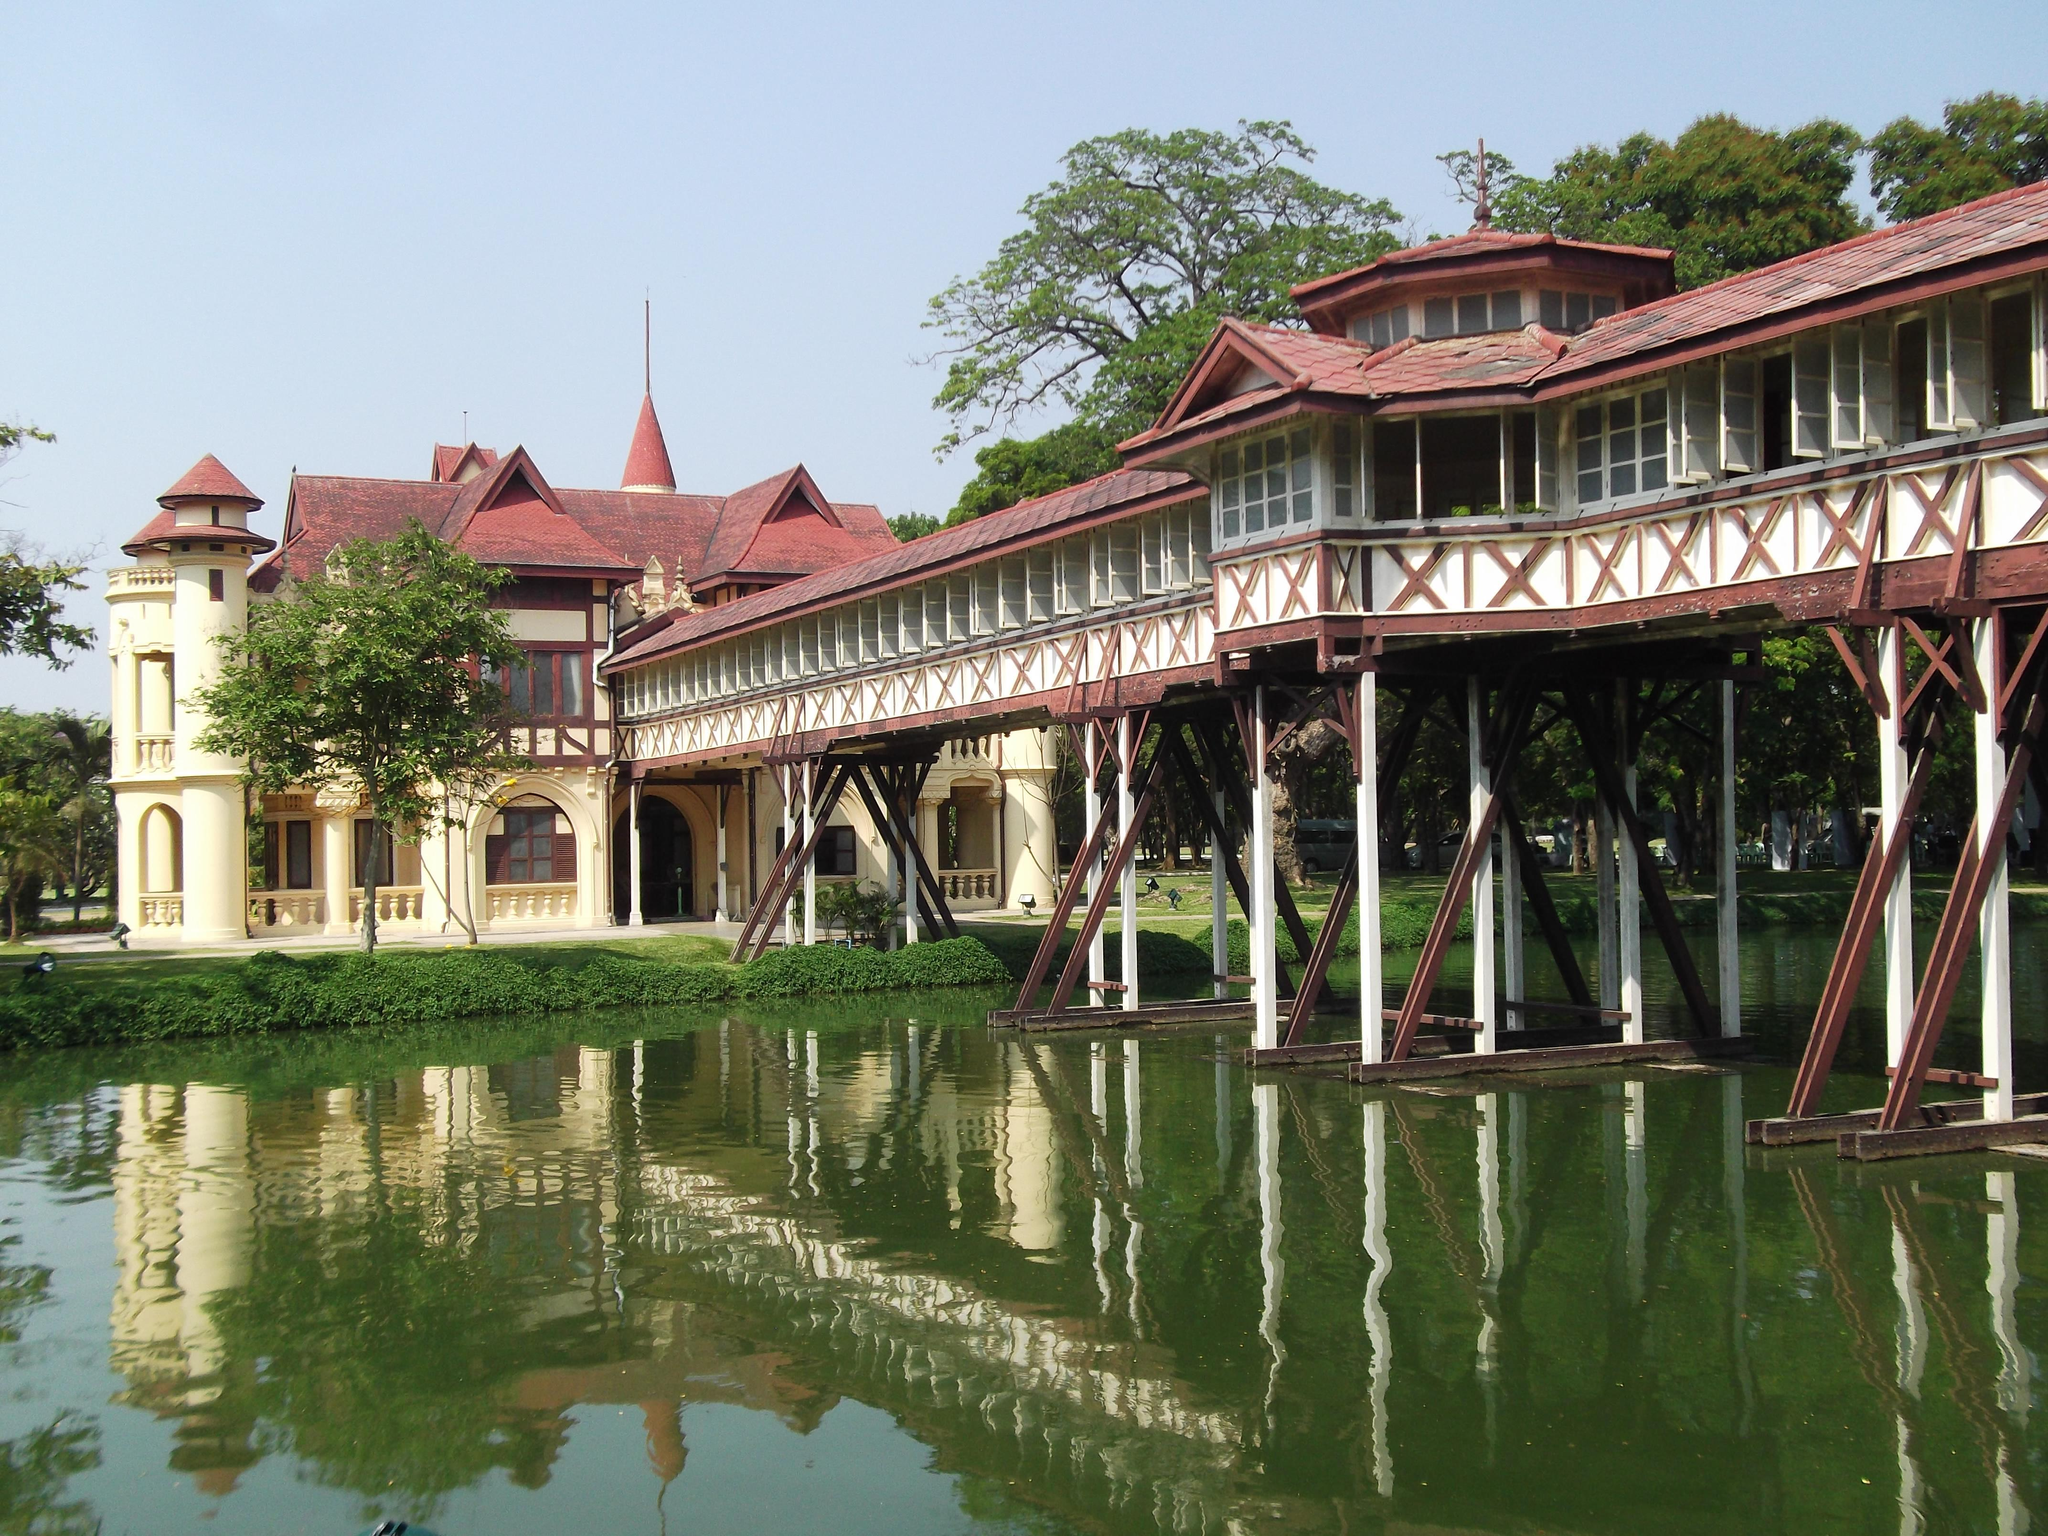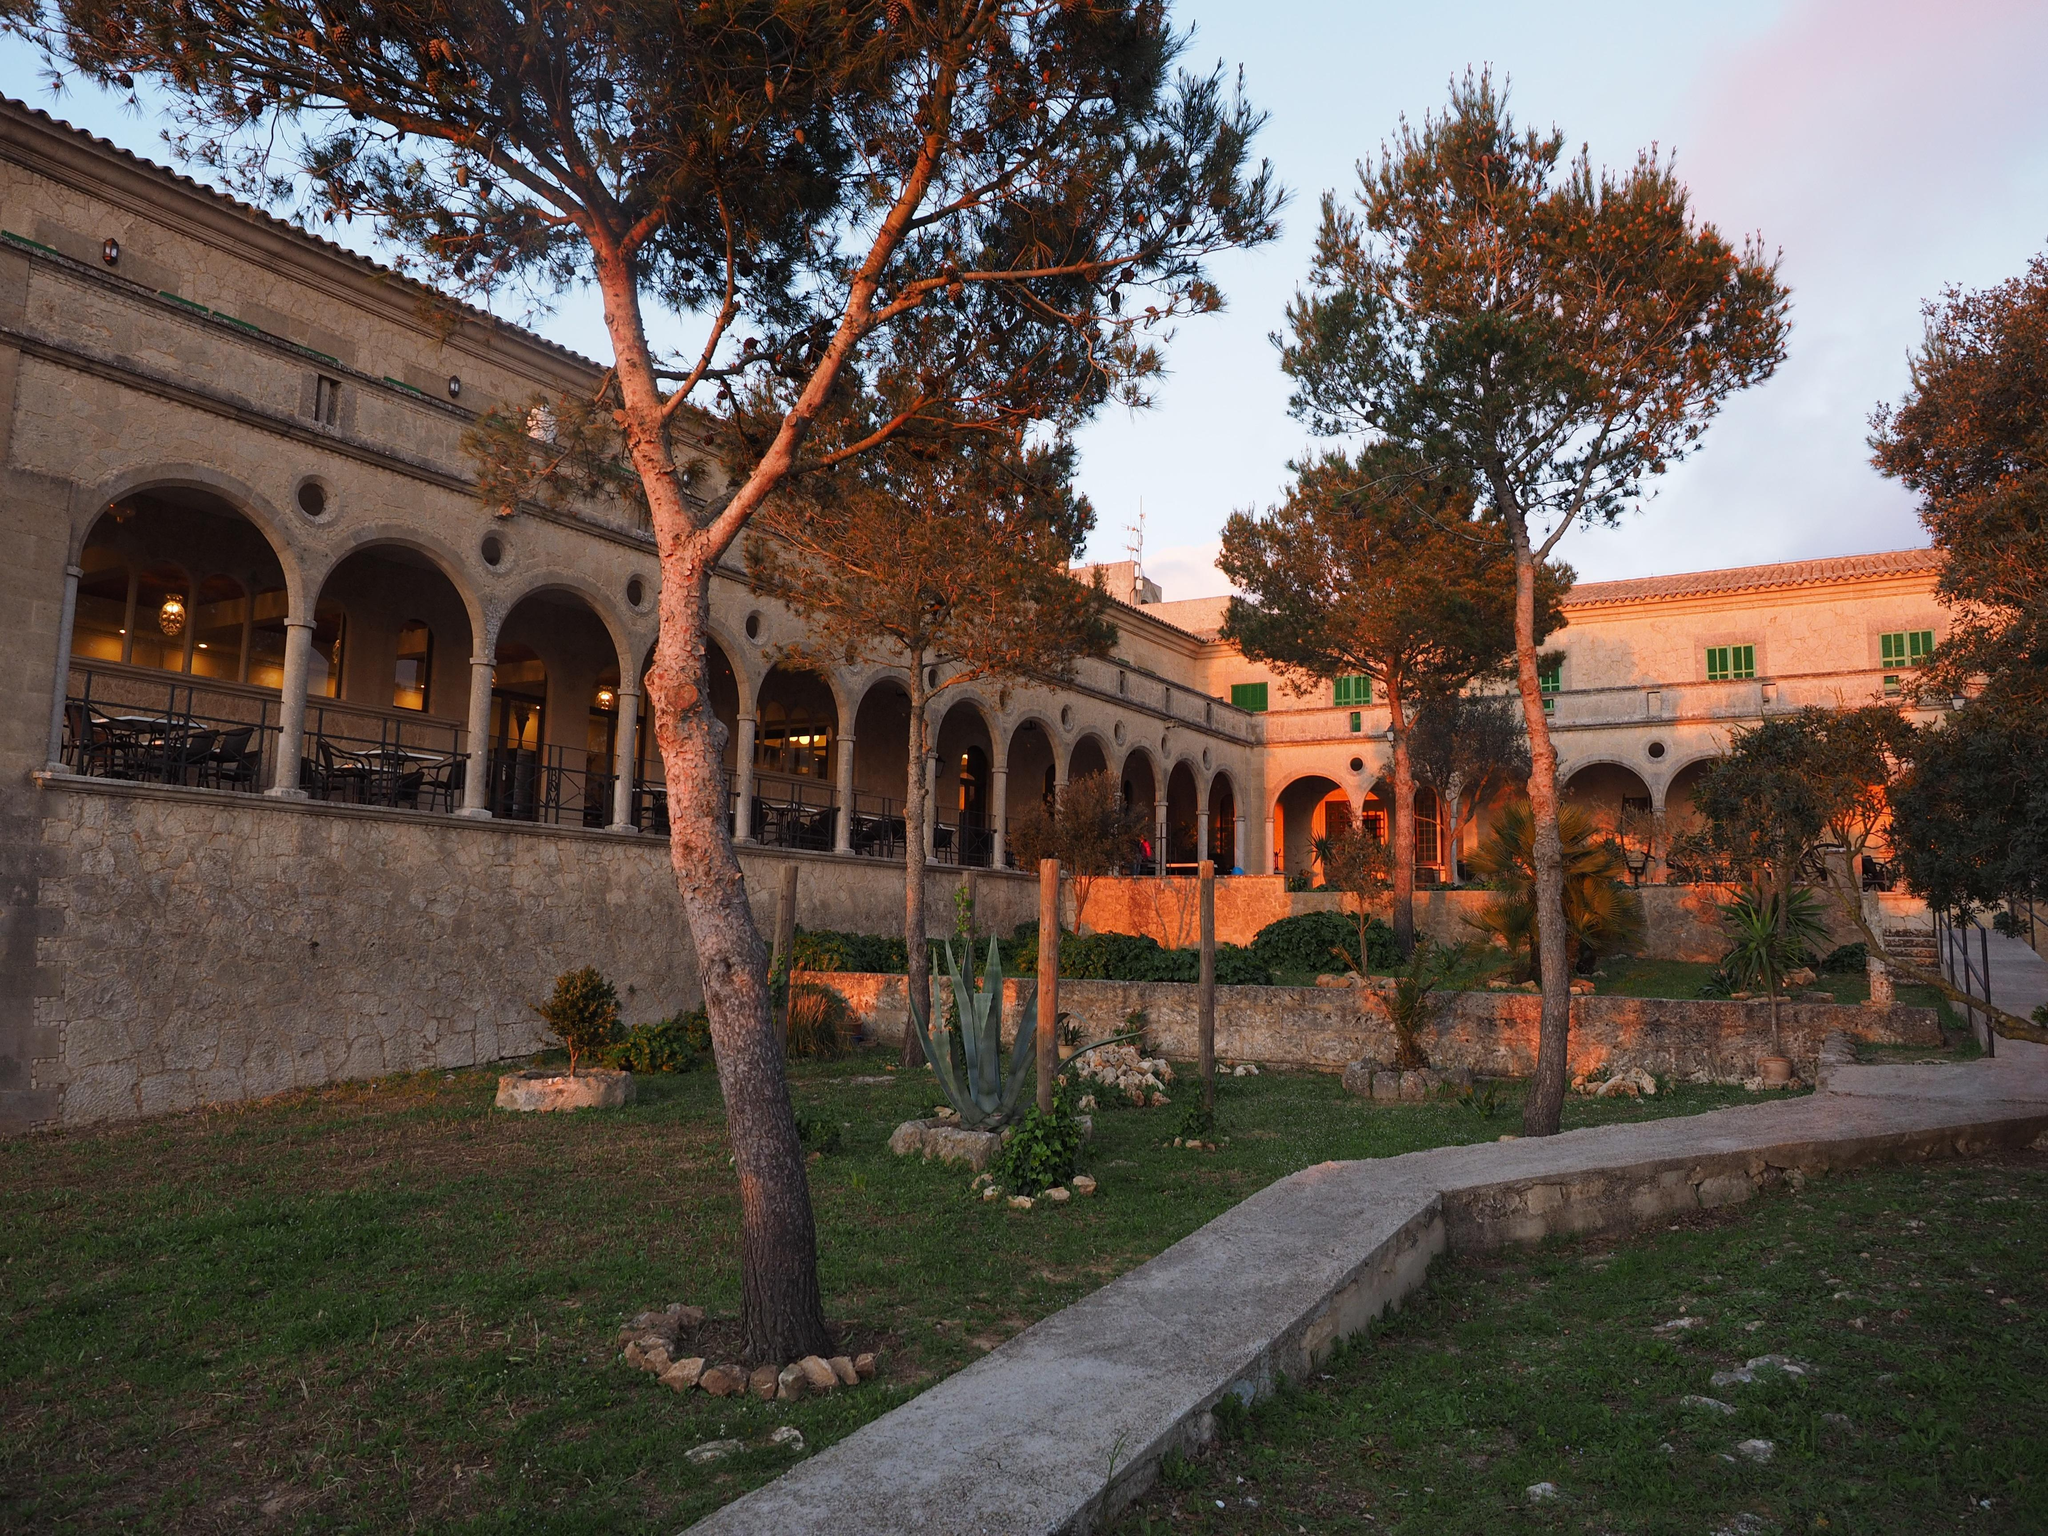The first image is the image on the left, the second image is the image on the right. Evaluate the accuracy of this statement regarding the images: "At least one image shows a seating area along a row of archways that overlooks a garden area.". Is it true? Answer yes or no. Yes. 